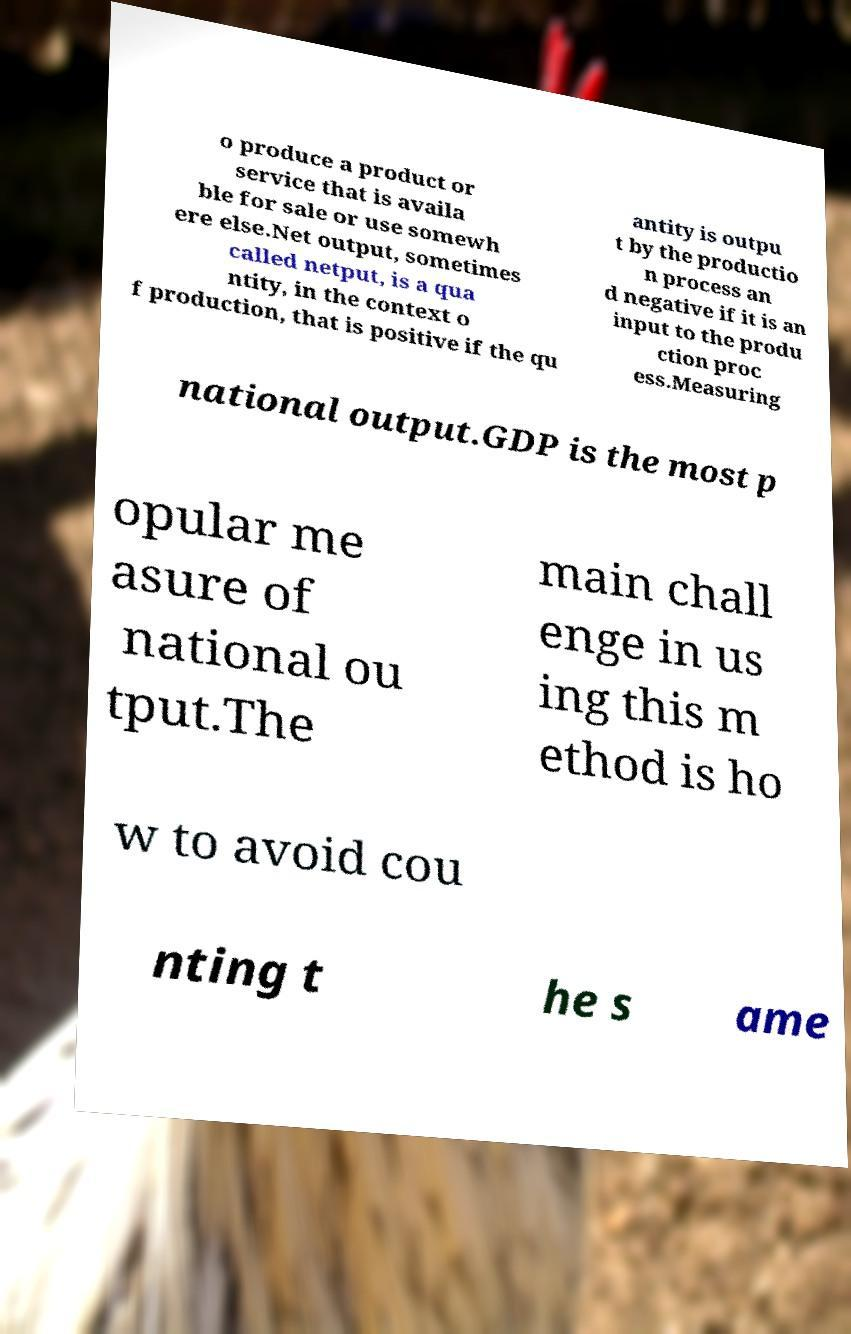For documentation purposes, I need the text within this image transcribed. Could you provide that? o produce a product or service that is availa ble for sale or use somewh ere else.Net output, sometimes called netput, is a qua ntity, in the context o f production, that is positive if the qu antity is outpu t by the productio n process an d negative if it is an input to the produ ction proc ess.Measuring national output.GDP is the most p opular me asure of national ou tput.The main chall enge in us ing this m ethod is ho w to avoid cou nting t he s ame 